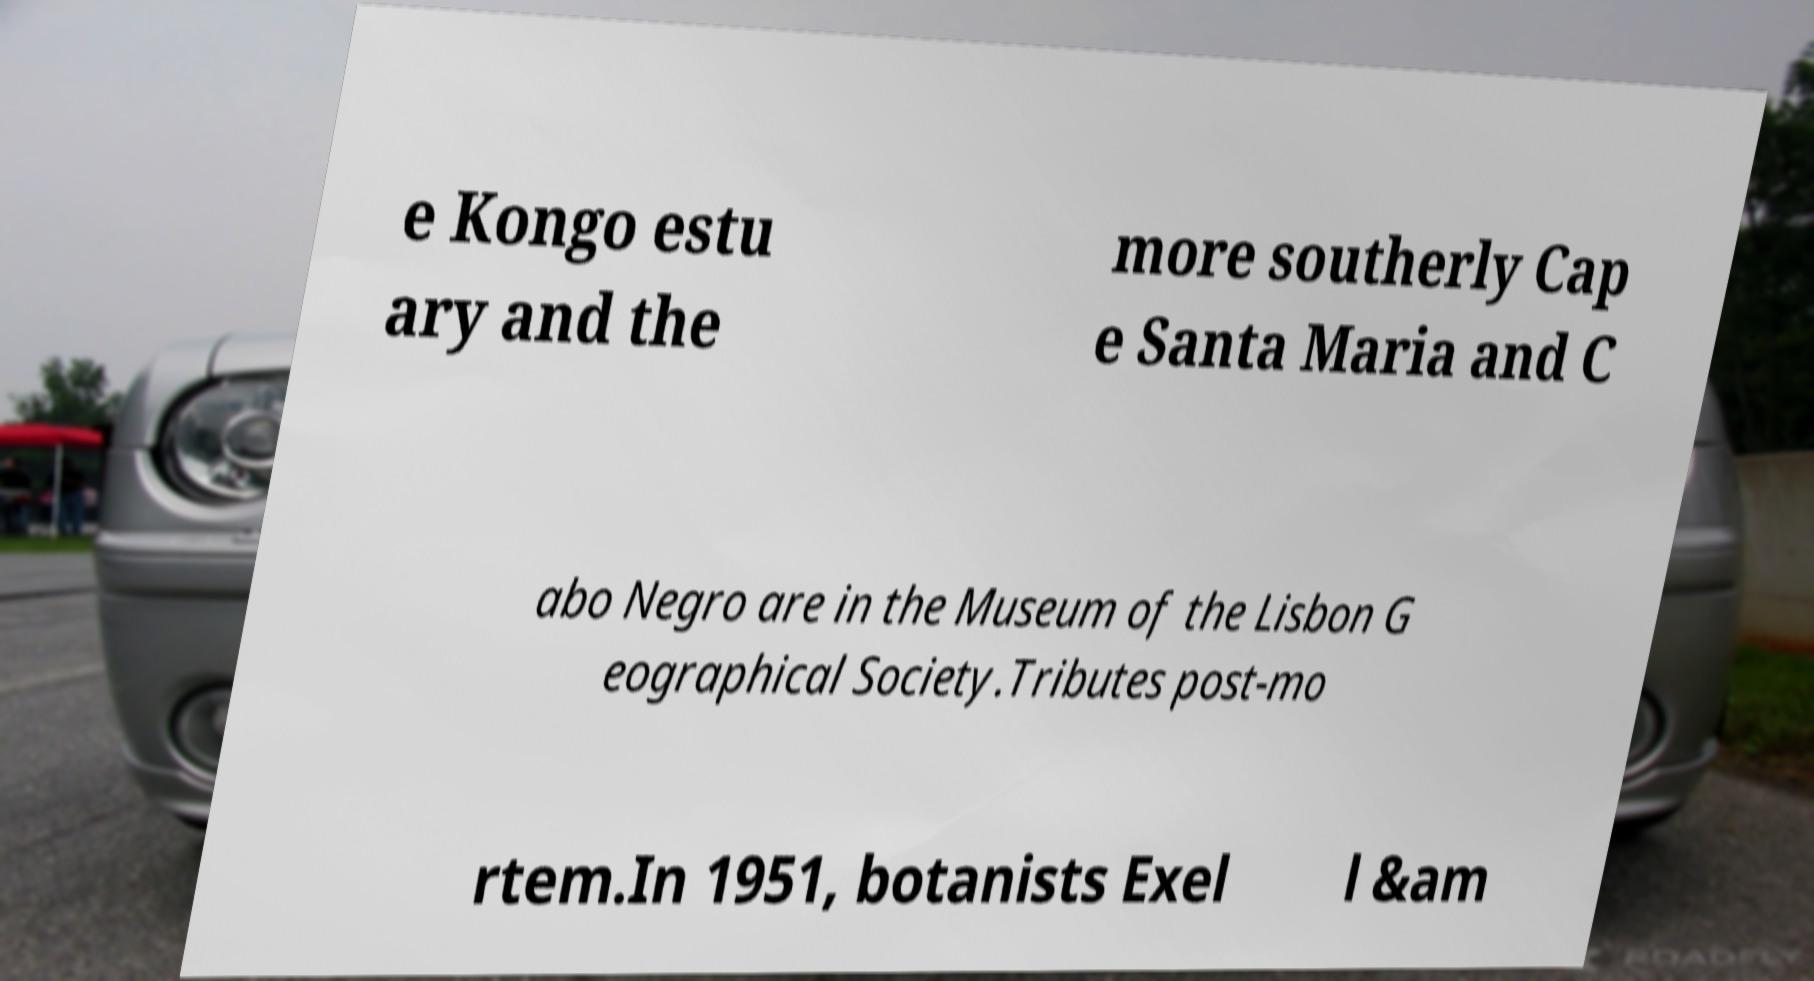Please read and relay the text visible in this image. What does it say? e Kongo estu ary and the more southerly Cap e Santa Maria and C abo Negro are in the Museum of the Lisbon G eographical Society.Tributes post-mo rtem.In 1951, botanists Exel l &am 